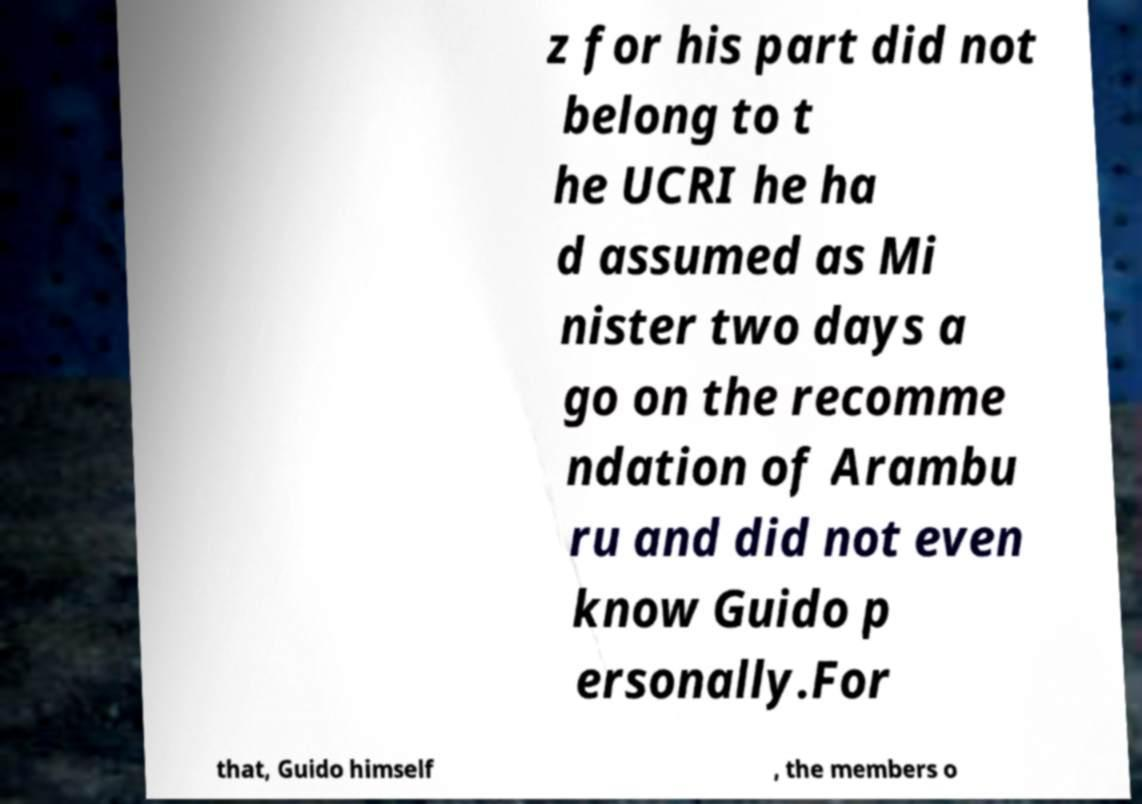Please identify and transcribe the text found in this image. z for his part did not belong to t he UCRI he ha d assumed as Mi nister two days a go on the recomme ndation of Arambu ru and did not even know Guido p ersonally.For that, Guido himself , the members o 